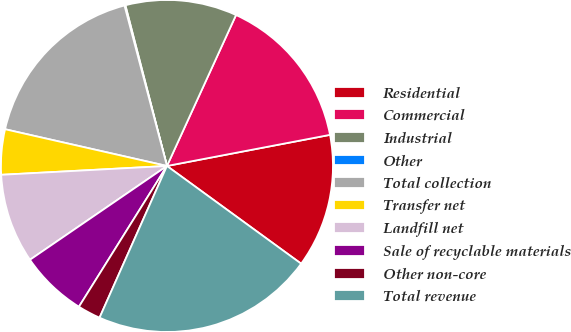Convert chart to OTSL. <chart><loc_0><loc_0><loc_500><loc_500><pie_chart><fcel>Residential<fcel>Commercial<fcel>Industrial<fcel>Other<fcel>Total collection<fcel>Transfer net<fcel>Landfill net<fcel>Sale of recyclable materials<fcel>Other non-core<fcel>Total revenue<nl><fcel>13.02%<fcel>15.17%<fcel>10.86%<fcel>0.09%<fcel>17.33%<fcel>4.4%<fcel>8.71%<fcel>6.55%<fcel>2.24%<fcel>21.64%<nl></chart> 